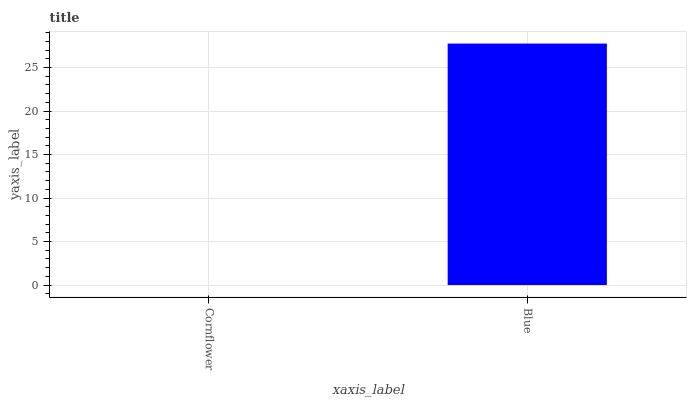Is Cornflower the minimum?
Answer yes or no. Yes. Is Blue the maximum?
Answer yes or no. Yes. Is Blue the minimum?
Answer yes or no. No. Is Blue greater than Cornflower?
Answer yes or no. Yes. Is Cornflower less than Blue?
Answer yes or no. Yes. Is Cornflower greater than Blue?
Answer yes or no. No. Is Blue less than Cornflower?
Answer yes or no. No. Is Blue the high median?
Answer yes or no. Yes. Is Cornflower the low median?
Answer yes or no. Yes. Is Cornflower the high median?
Answer yes or no. No. Is Blue the low median?
Answer yes or no. No. 